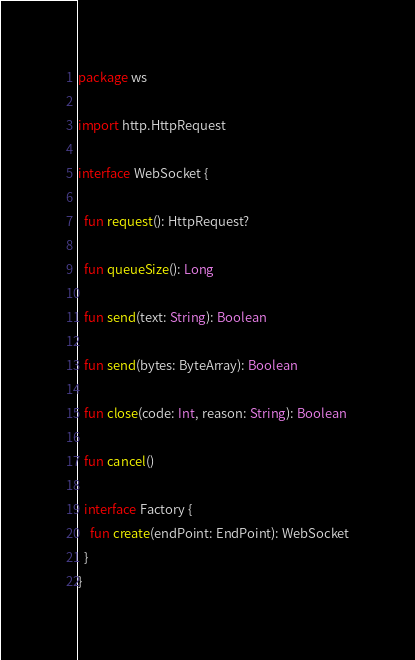Convert code to text. <code><loc_0><loc_0><loc_500><loc_500><_Kotlin_>package ws

import http.HttpRequest

interface WebSocket {

  fun request(): HttpRequest?

  fun queueSize(): Long

  fun send(text: String): Boolean

  fun send(bytes: ByteArray): Boolean

  fun close(code: Int, reason: String): Boolean

  fun cancel()

  interface Factory {
    fun create(endPoint: EndPoint): WebSocket
  }
}
</code> 